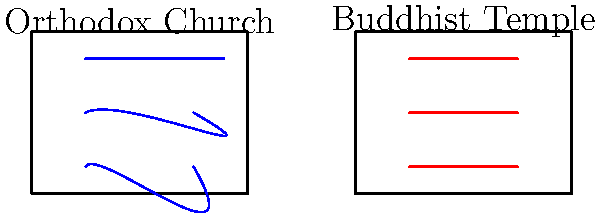How does the acoustic design of an Orthodox church typically differ from that of a Buddhist meditation hall, and what impact does this have on the sound experience during religious ceremonies? 1. Orthodox Church Acoustics:
   - Orthodox churches often have high, domed ceilings and hard surfaces (stone, marble).
   - This design creates reverberant spaces with long reverberation times (RT60).
   - Sound waves reflect multiple times, as shown by the curved blue lines in the diagram.
   - The reverberation time can be calculated using Sabine's formula: $RT60 = \frac{0.161 \times V}{A}$, where V is room volume and A is total absorption.

2. Buddhist Meditation Hall Acoustics:
   - Buddhist meditation halls typically have lower ceilings and use sound-absorbing materials.
   - This results in a more acoustically "dead" space with shorter reverberation times.
   - Sound waves travel more directly, as shown by the straight red lines in the diagram.
   - The absorption coefficient (α) of materials used is higher, reducing reflections.

3. Impact on Religious Ceremonies:
   - Orthodox churches: The reverberant acoustics enhance choral singing and chanting, creating a sense of awe and transcendence.
   - Buddhist temples: The controlled acoustics promote clarity of spoken words and allow for better concentration during meditation.

4. Sound Frequency Considerations:
   - Orthodox churches often amplify lower frequencies due to their architecture, enhancing male voices in chants.
   - Buddhist halls maintain a more balanced frequency response, suitable for spoken teachings and quiet meditation.

5. Acoustic Treatments:
   - Orthodox churches rarely use modern acoustic treatments to preserve traditional aesthetics.
   - Buddhist temples may incorporate subtle acoustic treatments to achieve desired sound quality.

The key difference lies in the intentional use of reverberation in Orthodox churches versus the controlled, absorptive environment in Buddhist meditation halls, each supporting their respective religious practices.
Answer: Orthodox churches have reverberant acoustics enhancing choral music, while Buddhist meditation halls have controlled acoustics for clarity and concentration. 